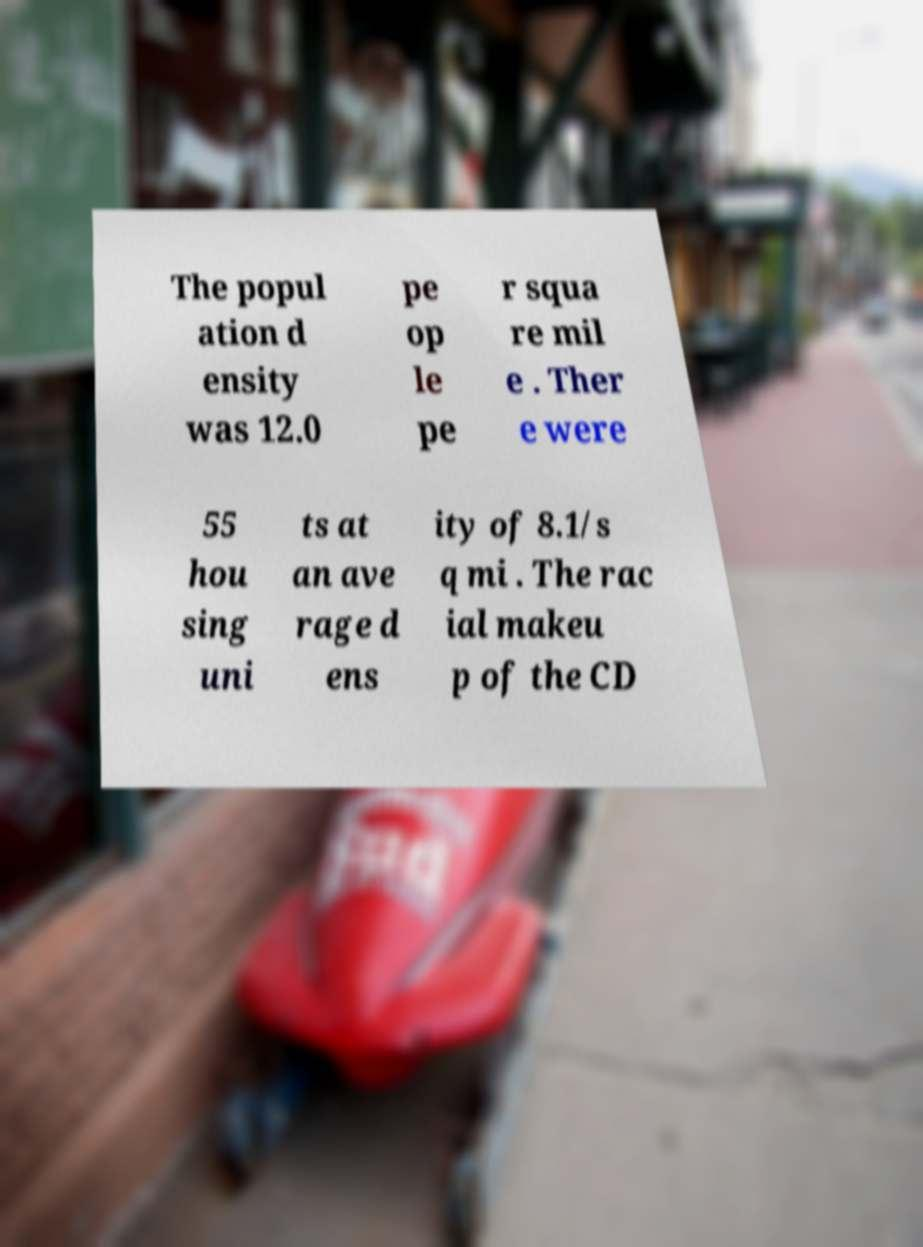Please read and relay the text visible in this image. What does it say? The popul ation d ensity was 12.0 pe op le pe r squa re mil e . Ther e were 55 hou sing uni ts at an ave rage d ens ity of 8.1/s q mi . The rac ial makeu p of the CD 